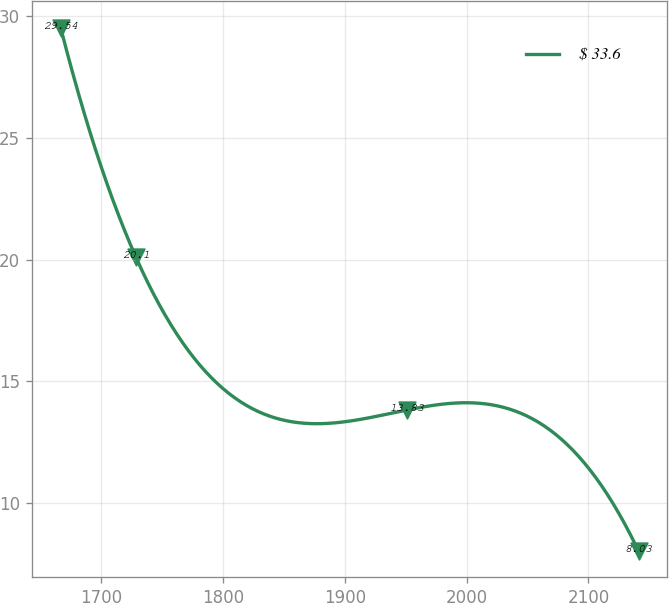Convert chart. <chart><loc_0><loc_0><loc_500><loc_500><line_chart><ecel><fcel>$ 33.6<nl><fcel>1666.49<fcel>29.54<nl><fcel>1728.37<fcel>20.1<nl><fcel>1951.28<fcel>13.83<nl><fcel>2141.18<fcel>8.03<nl></chart> 